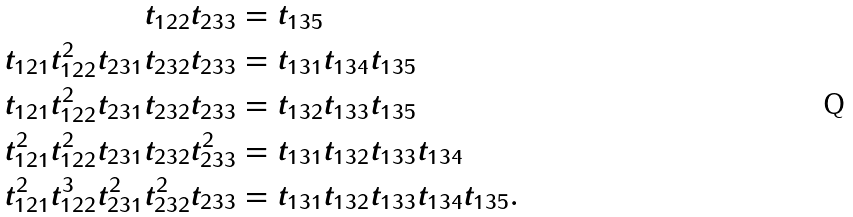<formula> <loc_0><loc_0><loc_500><loc_500>t _ { 1 2 2 } t _ { 2 3 3 } & = t _ { 1 3 5 } \\ t _ { 1 2 1 } t _ { 1 2 2 } ^ { 2 } t _ { 2 3 1 } t _ { 2 3 2 } t _ { 2 3 3 } & = t _ { 1 3 1 } t _ { 1 3 4 } t _ { 1 3 5 } \\ t _ { 1 2 1 } t _ { 1 2 2 } ^ { 2 } t _ { 2 3 1 } t _ { 2 3 2 } t _ { 2 3 3 } & = t _ { 1 3 2 } t _ { 1 3 3 } t _ { 1 3 5 } \\ t _ { 1 2 1 } ^ { 2 } t _ { 1 2 2 } ^ { 2 } t _ { 2 3 1 } t _ { 2 3 2 } t _ { 2 3 3 } ^ { 2 } & = t _ { 1 3 1 } t _ { 1 3 2 } t _ { 1 3 3 } t _ { 1 3 4 } \\ t _ { 1 2 1 } ^ { 2 } t _ { 1 2 2 } ^ { 3 } t _ { 2 3 1 } ^ { 2 } t _ { 2 3 2 } ^ { 2 } t _ { 2 3 3 } & = t _ { 1 3 1 } t _ { 1 3 2 } t _ { 1 3 3 } t _ { 1 3 4 } t _ { 1 3 5 } .</formula> 